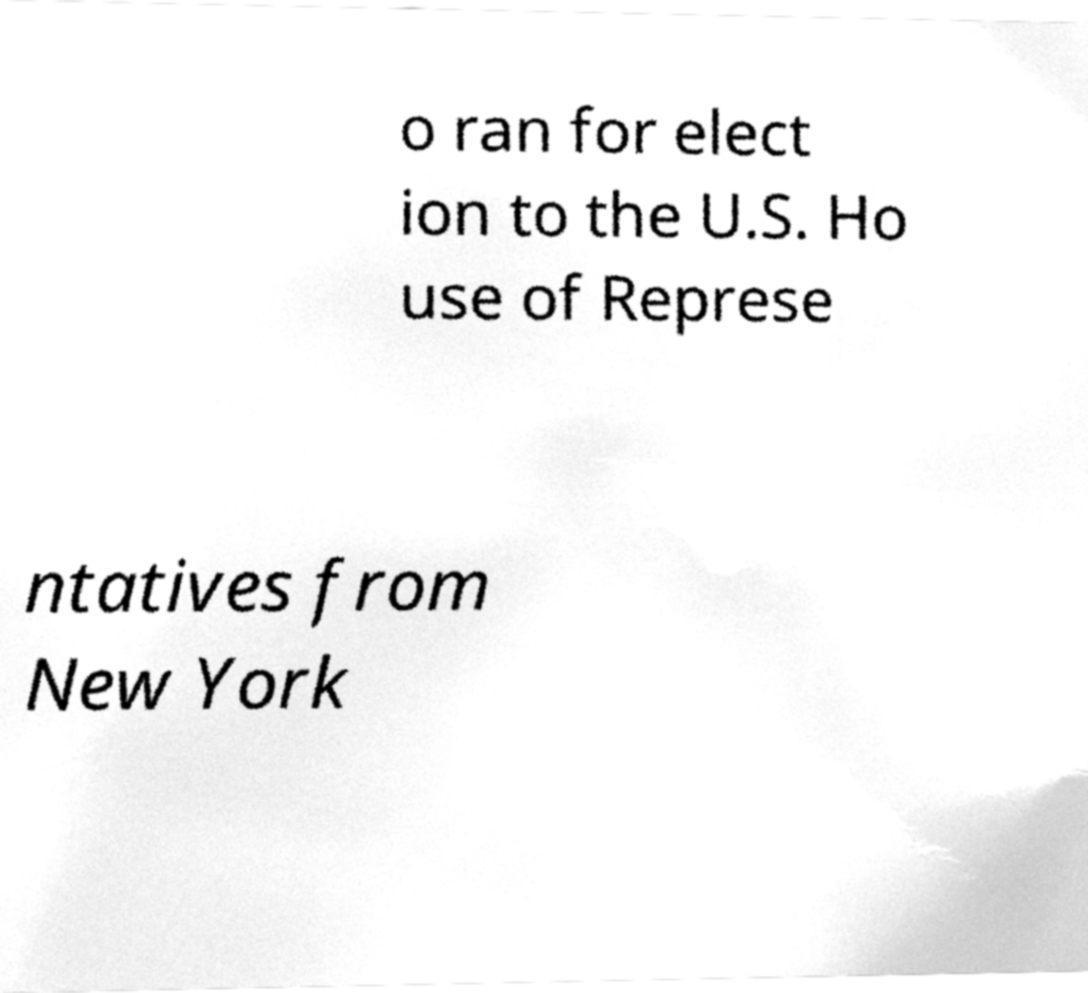Can you read and provide the text displayed in the image?This photo seems to have some interesting text. Can you extract and type it out for me? o ran for elect ion to the U.S. Ho use of Represe ntatives from New York 